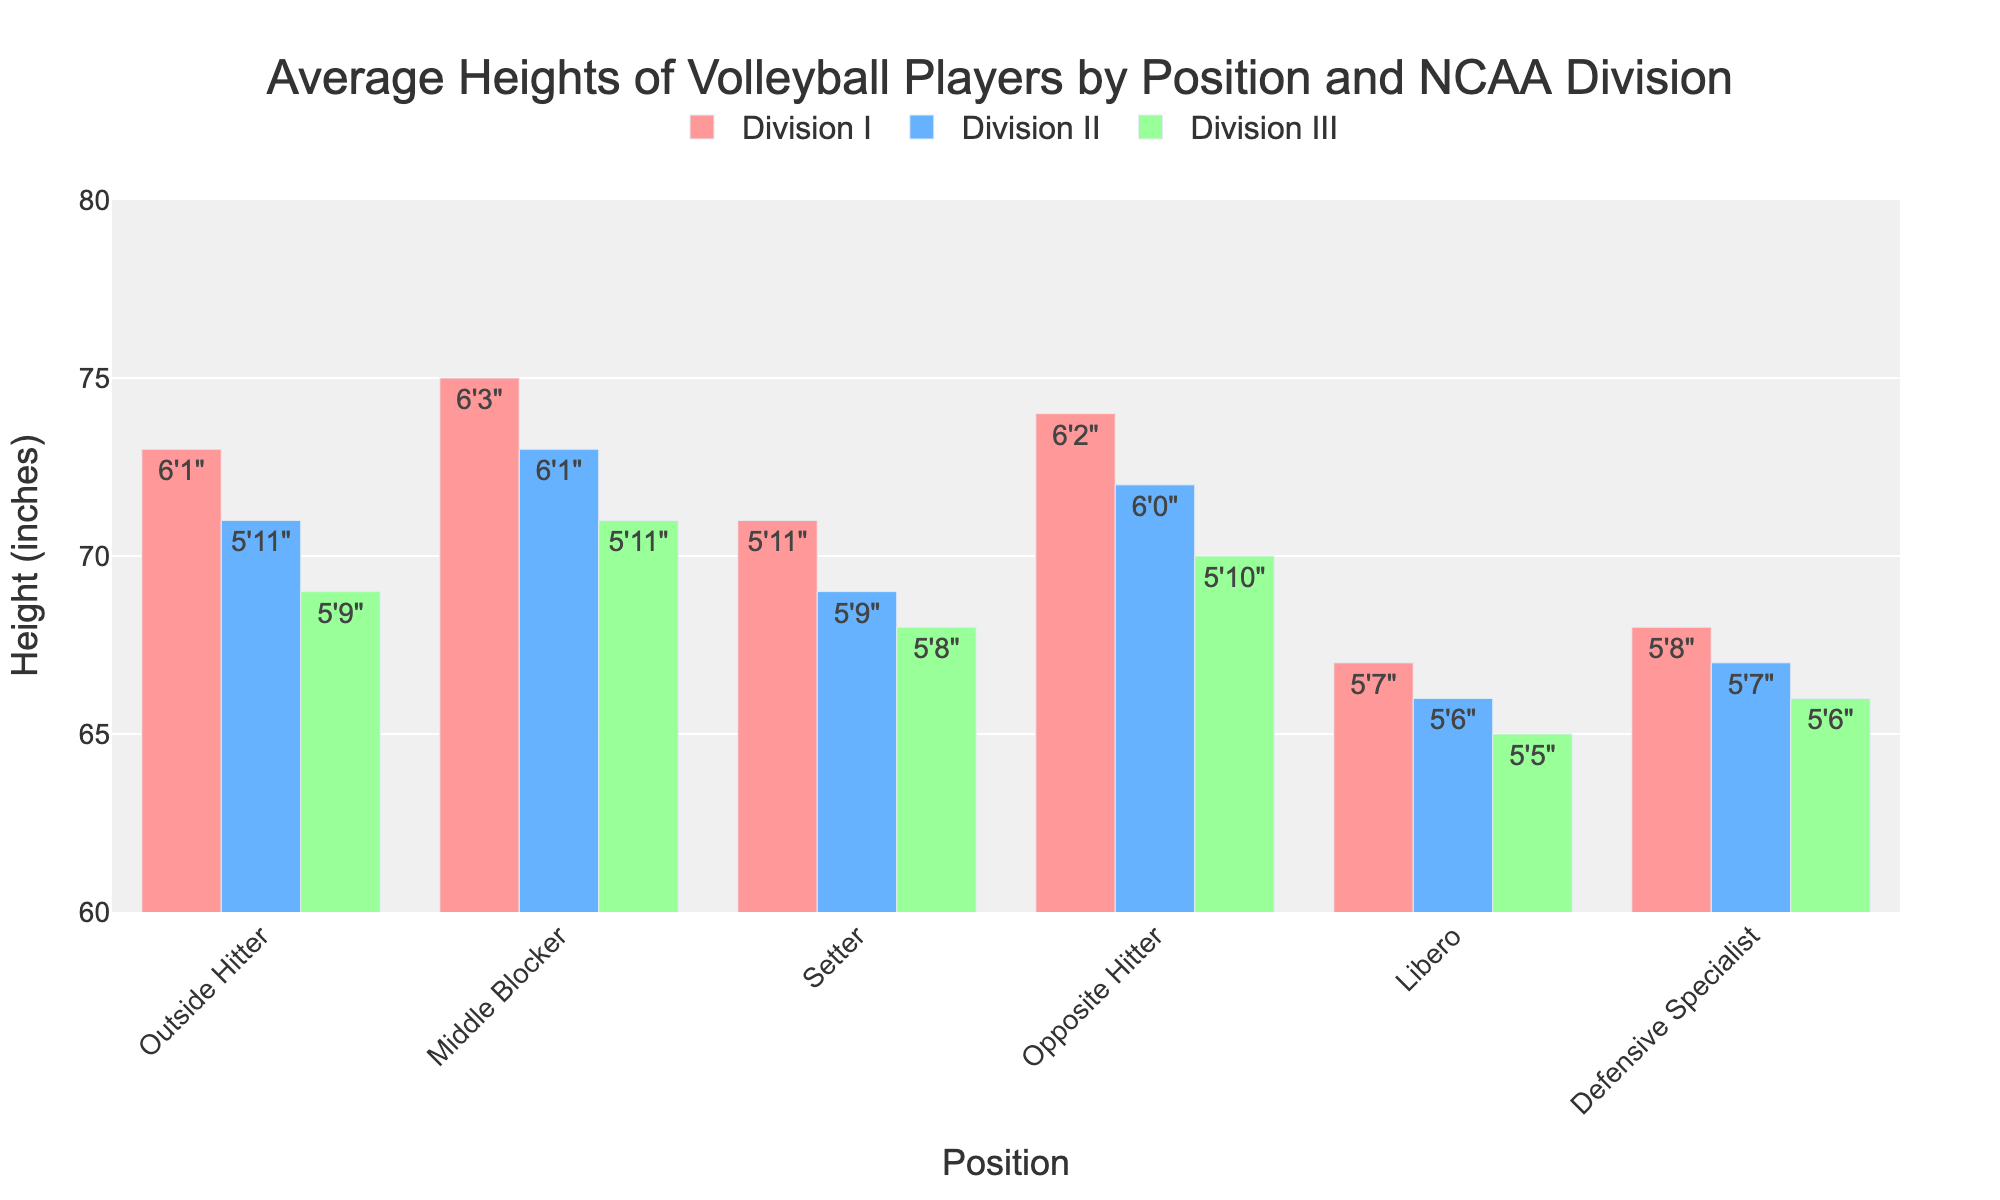Which position has the tallest average height in Division I? The tallest bar in Division I corresponds to the Middle Blocker position.
Answer: Middle Blocker How much taller on average is an Outside Hitter in Division I compared to Division III? The height of an Outside Hitter in Division I is 6'1" (73 inches) and in Division III is 5'9" (69 inches). The difference is 73 - 69 = 4 inches.
Answer: 4 inches Which position has the smallest height difference between Division I and Division II? The Setter position shows the smallest height difference between Division I (5'11" or 71 inches) and Division II (5'9" or 69 inches). The difference is 71 - 69 = 2 inches.
Answer: Setter Which division shows the greatest variability in player heights across different positions? By visually comparing the height ranges of the bars for each division, Division I shows greater variability in heights across different positions compared to Divisions II and III.
Answer: Division I How much shorter on average are Liberos compared to Opposite Hitters across all divisions? Convert heights to inches and calculate differences for each division.
- Division I: Opposite Hitter (74), Libero (67). Difference: 74 - 67 = 7.
- Division II: Opposite Hitter (72), Libero (66). Difference: 72 - 66 = 6.
- Division III: Opposite Hitter (70), Libero (65). Difference: 70 - 65 = 5.
- Average Difference: (7 + 6 + 5) / 3 = 6 inches.
Answer: 6 inches Which position has the shortest average height in Division II? The shortest bar in Division II corresponds to the Libero position.
Answer: Libero 